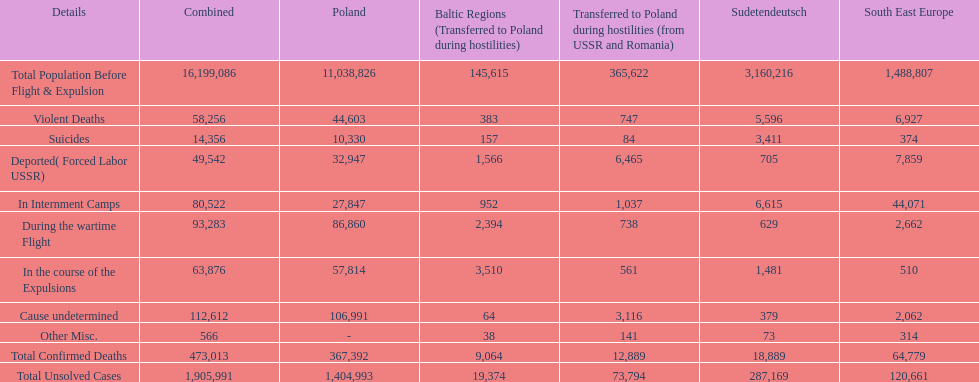Which country had the larger death tole? Poland. 